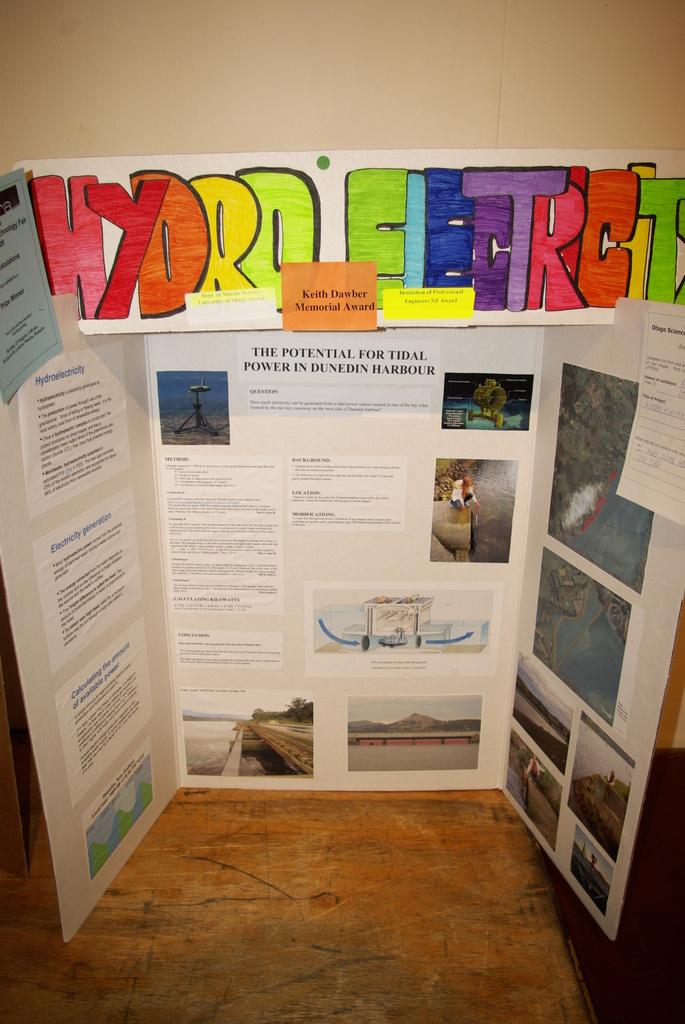Provide a one-sentence caption for the provided image. A hand made poster board presentation on hydro electricity. 